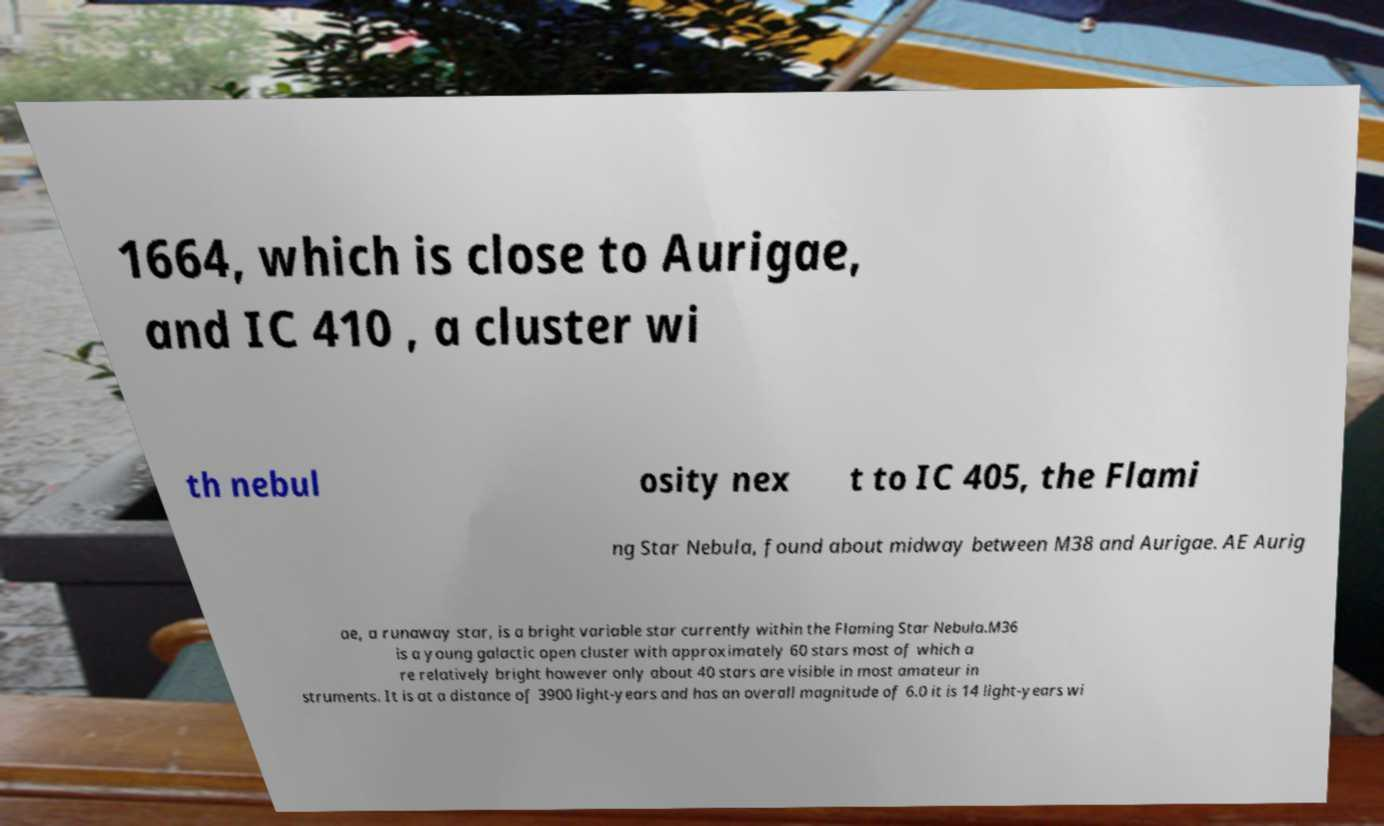Could you assist in decoding the text presented in this image and type it out clearly? 1664, which is close to Aurigae, and IC 410 , a cluster wi th nebul osity nex t to IC 405, the Flami ng Star Nebula, found about midway between M38 and Aurigae. AE Aurig ae, a runaway star, is a bright variable star currently within the Flaming Star Nebula.M36 is a young galactic open cluster with approximately 60 stars most of which a re relatively bright however only about 40 stars are visible in most amateur in struments. It is at a distance of 3900 light-years and has an overall magnitude of 6.0 it is 14 light-years wi 